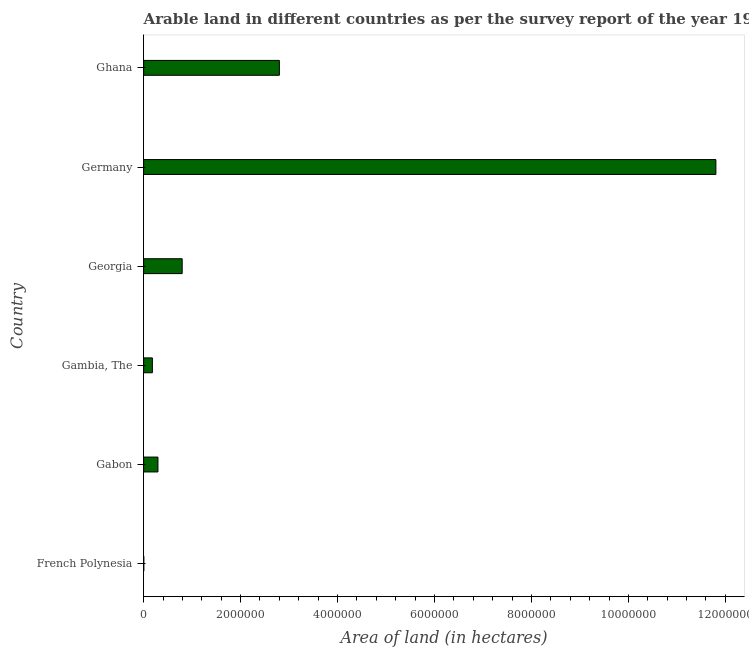Does the graph contain any zero values?
Offer a terse response. No. What is the title of the graph?
Offer a terse response. Arable land in different countries as per the survey report of the year 1994. What is the label or title of the X-axis?
Make the answer very short. Area of land (in hectares). What is the label or title of the Y-axis?
Provide a succinct answer. Country. What is the area of land in Germany?
Your response must be concise. 1.18e+07. Across all countries, what is the maximum area of land?
Offer a very short reply. 1.18e+07. Across all countries, what is the minimum area of land?
Ensure brevity in your answer.  3000. In which country was the area of land minimum?
Offer a very short reply. French Polynesia. What is the sum of the area of land?
Offer a very short reply. 1.59e+07. What is the difference between the area of land in Georgia and Germany?
Offer a very short reply. -1.10e+07. What is the average area of land per country?
Make the answer very short. 2.65e+06. What is the median area of land?
Offer a terse response. 5.45e+05. What is the ratio of the area of land in French Polynesia to that in Gabon?
Your answer should be very brief. 0.01. Is the area of land in French Polynesia less than that in Georgia?
Your answer should be very brief. Yes. What is the difference between the highest and the second highest area of land?
Provide a succinct answer. 9.00e+06. What is the difference between the highest and the lowest area of land?
Provide a succinct answer. 1.18e+07. Are all the bars in the graph horizontal?
Your answer should be compact. Yes. Are the values on the major ticks of X-axis written in scientific E-notation?
Provide a succinct answer. No. What is the Area of land (in hectares) in French Polynesia?
Keep it short and to the point. 3000. What is the Area of land (in hectares) in Gabon?
Your answer should be compact. 2.95e+05. What is the Area of land (in hectares) in Gambia, The?
Provide a short and direct response. 1.80e+05. What is the Area of land (in hectares) of Georgia?
Your answer should be very brief. 7.95e+05. What is the Area of land (in hectares) in Germany?
Your response must be concise. 1.18e+07. What is the Area of land (in hectares) in Ghana?
Provide a succinct answer. 2.80e+06. What is the difference between the Area of land (in hectares) in French Polynesia and Gabon?
Give a very brief answer. -2.92e+05. What is the difference between the Area of land (in hectares) in French Polynesia and Gambia, The?
Your answer should be compact. -1.77e+05. What is the difference between the Area of land (in hectares) in French Polynesia and Georgia?
Offer a very short reply. -7.92e+05. What is the difference between the Area of land (in hectares) in French Polynesia and Germany?
Provide a short and direct response. -1.18e+07. What is the difference between the Area of land (in hectares) in French Polynesia and Ghana?
Your answer should be compact. -2.80e+06. What is the difference between the Area of land (in hectares) in Gabon and Gambia, The?
Provide a short and direct response. 1.15e+05. What is the difference between the Area of land (in hectares) in Gabon and Georgia?
Make the answer very short. -5.00e+05. What is the difference between the Area of land (in hectares) in Gabon and Germany?
Make the answer very short. -1.15e+07. What is the difference between the Area of land (in hectares) in Gabon and Ghana?
Your answer should be very brief. -2.50e+06. What is the difference between the Area of land (in hectares) in Gambia, The and Georgia?
Your answer should be compact. -6.15e+05. What is the difference between the Area of land (in hectares) in Gambia, The and Germany?
Offer a terse response. -1.16e+07. What is the difference between the Area of land (in hectares) in Gambia, The and Ghana?
Your response must be concise. -2.62e+06. What is the difference between the Area of land (in hectares) in Georgia and Germany?
Provide a succinct answer. -1.10e+07. What is the difference between the Area of land (in hectares) in Georgia and Ghana?
Ensure brevity in your answer.  -2.00e+06. What is the difference between the Area of land (in hectares) in Germany and Ghana?
Your response must be concise. 9.00e+06. What is the ratio of the Area of land (in hectares) in French Polynesia to that in Gabon?
Give a very brief answer. 0.01. What is the ratio of the Area of land (in hectares) in French Polynesia to that in Gambia, The?
Provide a short and direct response. 0.02. What is the ratio of the Area of land (in hectares) in French Polynesia to that in Georgia?
Give a very brief answer. 0. What is the ratio of the Area of land (in hectares) in French Polynesia to that in Germany?
Your answer should be compact. 0. What is the ratio of the Area of land (in hectares) in Gabon to that in Gambia, The?
Make the answer very short. 1.64. What is the ratio of the Area of land (in hectares) in Gabon to that in Georgia?
Your answer should be very brief. 0.37. What is the ratio of the Area of land (in hectares) in Gabon to that in Germany?
Give a very brief answer. 0.03. What is the ratio of the Area of land (in hectares) in Gabon to that in Ghana?
Provide a succinct answer. 0.1. What is the ratio of the Area of land (in hectares) in Gambia, The to that in Georgia?
Make the answer very short. 0.23. What is the ratio of the Area of land (in hectares) in Gambia, The to that in Germany?
Your answer should be very brief. 0.01. What is the ratio of the Area of land (in hectares) in Gambia, The to that in Ghana?
Your answer should be very brief. 0.06. What is the ratio of the Area of land (in hectares) in Georgia to that in Germany?
Offer a very short reply. 0.07. What is the ratio of the Area of land (in hectares) in Georgia to that in Ghana?
Provide a short and direct response. 0.28. What is the ratio of the Area of land (in hectares) in Germany to that in Ghana?
Your answer should be compact. 4.22. 